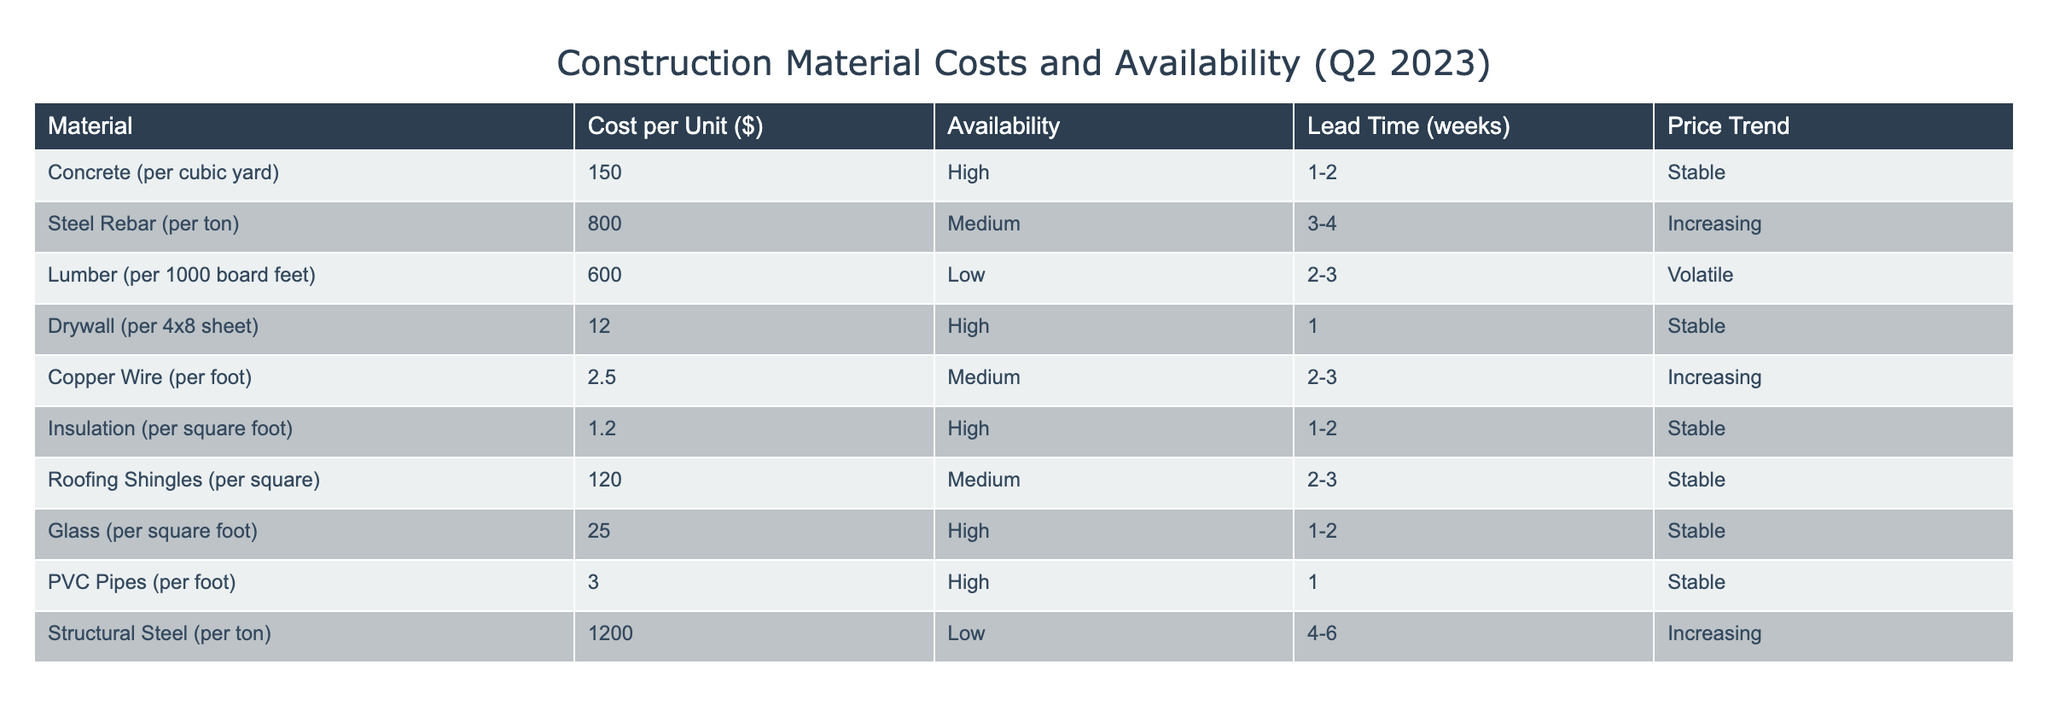What is the cost of Concrete per cubic yard? The cost of Concrete per cubic yard is listed directly in the table under the "Cost per Unit ($)" column for Concrete. It states 150.
Answer: 150 How many weeks of lead time are required for Steel Rebar? The lead time for Steel Rebar is found in the "Lead Time (weeks)" column for this material. It shows a range of 3 to 4 weeks.
Answer: 3-4 weeks Which materials have high availability? To find materials with high availability, we can filter the "Availability" column for values marked as "High". By examining the table, the materials with high availability are Concrete, Drywall, Insulation, Glass, and PVC Pipes.
Answer: Concrete, Drywall, Insulation, Glass, PVC Pipes What is the total cost per unit of Lumber and Copper Wire? The costs per unit for Lumber and Copper Wire are found in the "Cost per Unit ($)" column, where Lumber is 600 and Copper Wire is 2.5. Adding these together gives us 600 + 2.5 = 602.5.
Answer: 602.5 Is the price trend for Structural Steel increasing? We can find the price trend for Structural Steel in the "Price Trend" column. It is indicated as "Increasing". Therefore, the statement is true.
Answer: Yes What material has the longest lead time and what is that lead time? To determine the longest lead time, we need to compare the lead times in the "Lead Time (weeks)" column. Structural Steel has a range of 4 to 6 weeks, which is the longest when compared to others.
Answer: 4-6 weeks If we average the costs of all materials listed, what is the result? To find the average cost, we first sum up all the individual costs per unit from the "Cost per Unit ($)" column: 150 + 800 + 600 + 12 + 2.5 + 1.2 + 120 + 25 + 3 + 1200 = 2913. Then, we divide this sum by the total number of materials (10): 2913 / 10 = 291.3.
Answer: 291.3 Is Copper Wire less expensive than Drywall? Comparing the costs from the "Cost per Unit ($)" column, Copper Wire is 2.5 and Drywall is 12. Since 2.5 is less than 12, the statement is true.
Answer: Yes 